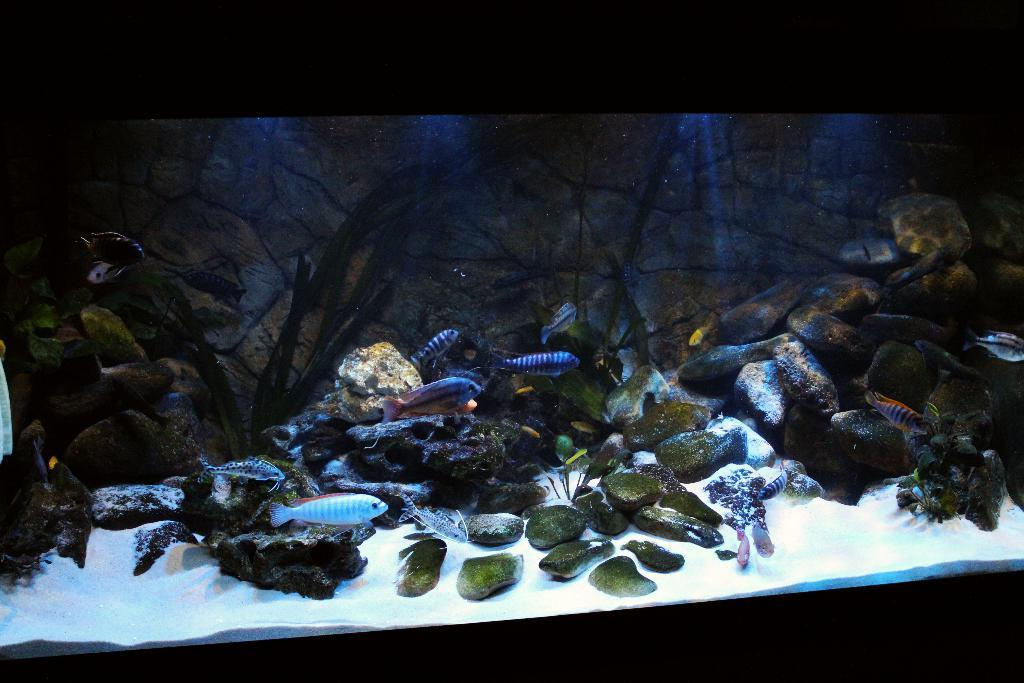What type of environment is depicted in the image? The image appears to be an aquarium. What can be seen moving in the water? There are different types of fishes moving in the water. What other objects are visible in the image? There are rocks visible in the image. What is visible in the background of the image? There is a wall in the background of the image. Are there any snakes visible in the image? No, there are no snakes visible in the image; it is an aquarium with fishes in the water. What type of show is being performed in the image? There is no show being performed in the image; it is a static scene of an aquarium with fishes and rocks. 